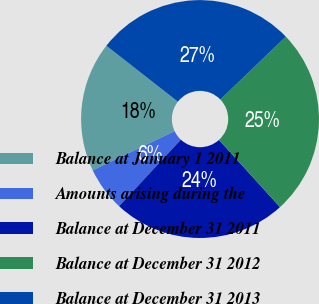Convert chart to OTSL. <chart><loc_0><loc_0><loc_500><loc_500><pie_chart><fcel>Balance at January 1 2011<fcel>Amounts arising during the<fcel>Balance at December 31 2011<fcel>Balance at December 31 2012<fcel>Balance at December 31 2013<nl><fcel>17.66%<fcel>5.99%<fcel>23.65%<fcel>25.45%<fcel>27.25%<nl></chart> 